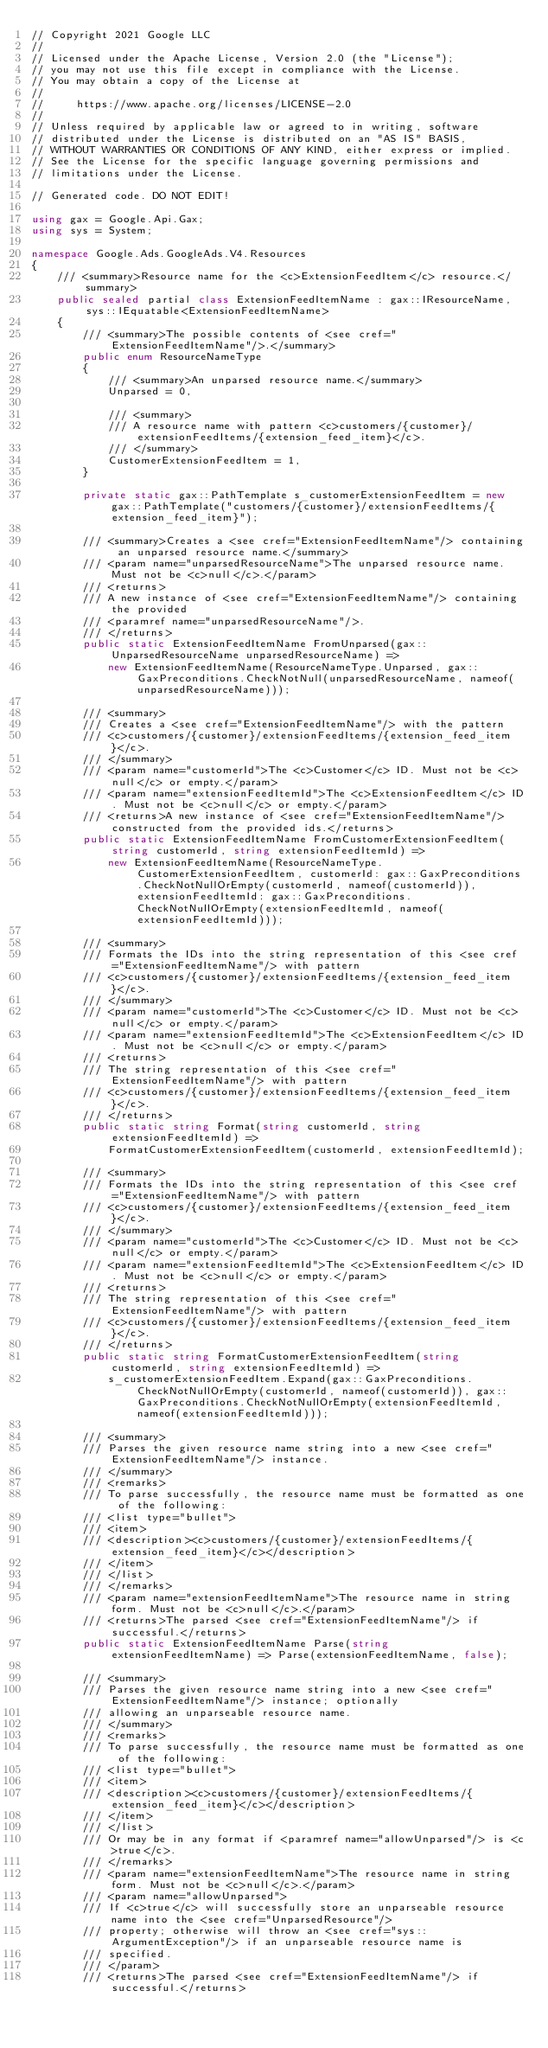Convert code to text. <code><loc_0><loc_0><loc_500><loc_500><_C#_>// Copyright 2021 Google LLC
//
// Licensed under the Apache License, Version 2.0 (the "License");
// you may not use this file except in compliance with the License.
// You may obtain a copy of the License at
//
//     https://www.apache.org/licenses/LICENSE-2.0
//
// Unless required by applicable law or agreed to in writing, software
// distributed under the License is distributed on an "AS IS" BASIS,
// WITHOUT WARRANTIES OR CONDITIONS OF ANY KIND, either express or implied.
// See the License for the specific language governing permissions and
// limitations under the License.

// Generated code. DO NOT EDIT!

using gax = Google.Api.Gax;
using sys = System;

namespace Google.Ads.GoogleAds.V4.Resources
{
    /// <summary>Resource name for the <c>ExtensionFeedItem</c> resource.</summary>
    public sealed partial class ExtensionFeedItemName : gax::IResourceName, sys::IEquatable<ExtensionFeedItemName>
    {
        /// <summary>The possible contents of <see cref="ExtensionFeedItemName"/>.</summary>
        public enum ResourceNameType
        {
            /// <summary>An unparsed resource name.</summary>
            Unparsed = 0,

            /// <summary>
            /// A resource name with pattern <c>customers/{customer}/extensionFeedItems/{extension_feed_item}</c>.
            /// </summary>
            CustomerExtensionFeedItem = 1,
        }

        private static gax::PathTemplate s_customerExtensionFeedItem = new gax::PathTemplate("customers/{customer}/extensionFeedItems/{extension_feed_item}");

        /// <summary>Creates a <see cref="ExtensionFeedItemName"/> containing an unparsed resource name.</summary>
        /// <param name="unparsedResourceName">The unparsed resource name. Must not be <c>null</c>.</param>
        /// <returns>
        /// A new instance of <see cref="ExtensionFeedItemName"/> containing the provided
        /// <paramref name="unparsedResourceName"/>.
        /// </returns>
        public static ExtensionFeedItemName FromUnparsed(gax::UnparsedResourceName unparsedResourceName) =>
            new ExtensionFeedItemName(ResourceNameType.Unparsed, gax::GaxPreconditions.CheckNotNull(unparsedResourceName, nameof(unparsedResourceName)));

        /// <summary>
        /// Creates a <see cref="ExtensionFeedItemName"/> with the pattern
        /// <c>customers/{customer}/extensionFeedItems/{extension_feed_item}</c>.
        /// </summary>
        /// <param name="customerId">The <c>Customer</c> ID. Must not be <c>null</c> or empty.</param>
        /// <param name="extensionFeedItemId">The <c>ExtensionFeedItem</c> ID. Must not be <c>null</c> or empty.</param>
        /// <returns>A new instance of <see cref="ExtensionFeedItemName"/> constructed from the provided ids.</returns>
        public static ExtensionFeedItemName FromCustomerExtensionFeedItem(string customerId, string extensionFeedItemId) =>
            new ExtensionFeedItemName(ResourceNameType.CustomerExtensionFeedItem, customerId: gax::GaxPreconditions.CheckNotNullOrEmpty(customerId, nameof(customerId)), extensionFeedItemId: gax::GaxPreconditions.CheckNotNullOrEmpty(extensionFeedItemId, nameof(extensionFeedItemId)));

        /// <summary>
        /// Formats the IDs into the string representation of this <see cref="ExtensionFeedItemName"/> with pattern
        /// <c>customers/{customer}/extensionFeedItems/{extension_feed_item}</c>.
        /// </summary>
        /// <param name="customerId">The <c>Customer</c> ID. Must not be <c>null</c> or empty.</param>
        /// <param name="extensionFeedItemId">The <c>ExtensionFeedItem</c> ID. Must not be <c>null</c> or empty.</param>
        /// <returns>
        /// The string representation of this <see cref="ExtensionFeedItemName"/> with pattern
        /// <c>customers/{customer}/extensionFeedItems/{extension_feed_item}</c>.
        /// </returns>
        public static string Format(string customerId, string extensionFeedItemId) =>
            FormatCustomerExtensionFeedItem(customerId, extensionFeedItemId);

        /// <summary>
        /// Formats the IDs into the string representation of this <see cref="ExtensionFeedItemName"/> with pattern
        /// <c>customers/{customer}/extensionFeedItems/{extension_feed_item}</c>.
        /// </summary>
        /// <param name="customerId">The <c>Customer</c> ID. Must not be <c>null</c> or empty.</param>
        /// <param name="extensionFeedItemId">The <c>ExtensionFeedItem</c> ID. Must not be <c>null</c> or empty.</param>
        /// <returns>
        /// The string representation of this <see cref="ExtensionFeedItemName"/> with pattern
        /// <c>customers/{customer}/extensionFeedItems/{extension_feed_item}</c>.
        /// </returns>
        public static string FormatCustomerExtensionFeedItem(string customerId, string extensionFeedItemId) =>
            s_customerExtensionFeedItem.Expand(gax::GaxPreconditions.CheckNotNullOrEmpty(customerId, nameof(customerId)), gax::GaxPreconditions.CheckNotNullOrEmpty(extensionFeedItemId, nameof(extensionFeedItemId)));

        /// <summary>
        /// Parses the given resource name string into a new <see cref="ExtensionFeedItemName"/> instance.
        /// </summary>
        /// <remarks>
        /// To parse successfully, the resource name must be formatted as one of the following:
        /// <list type="bullet">
        /// <item>
        /// <description><c>customers/{customer}/extensionFeedItems/{extension_feed_item}</c></description>
        /// </item>
        /// </list>
        /// </remarks>
        /// <param name="extensionFeedItemName">The resource name in string form. Must not be <c>null</c>.</param>
        /// <returns>The parsed <see cref="ExtensionFeedItemName"/> if successful.</returns>
        public static ExtensionFeedItemName Parse(string extensionFeedItemName) => Parse(extensionFeedItemName, false);

        /// <summary>
        /// Parses the given resource name string into a new <see cref="ExtensionFeedItemName"/> instance; optionally
        /// allowing an unparseable resource name.
        /// </summary>
        /// <remarks>
        /// To parse successfully, the resource name must be formatted as one of the following:
        /// <list type="bullet">
        /// <item>
        /// <description><c>customers/{customer}/extensionFeedItems/{extension_feed_item}</c></description>
        /// </item>
        /// </list>
        /// Or may be in any format if <paramref name="allowUnparsed"/> is <c>true</c>.
        /// </remarks>
        /// <param name="extensionFeedItemName">The resource name in string form. Must not be <c>null</c>.</param>
        /// <param name="allowUnparsed">
        /// If <c>true</c> will successfully store an unparseable resource name into the <see cref="UnparsedResource"/>
        /// property; otherwise will throw an <see cref="sys::ArgumentException"/> if an unparseable resource name is
        /// specified.
        /// </param>
        /// <returns>The parsed <see cref="ExtensionFeedItemName"/> if successful.</returns></code> 